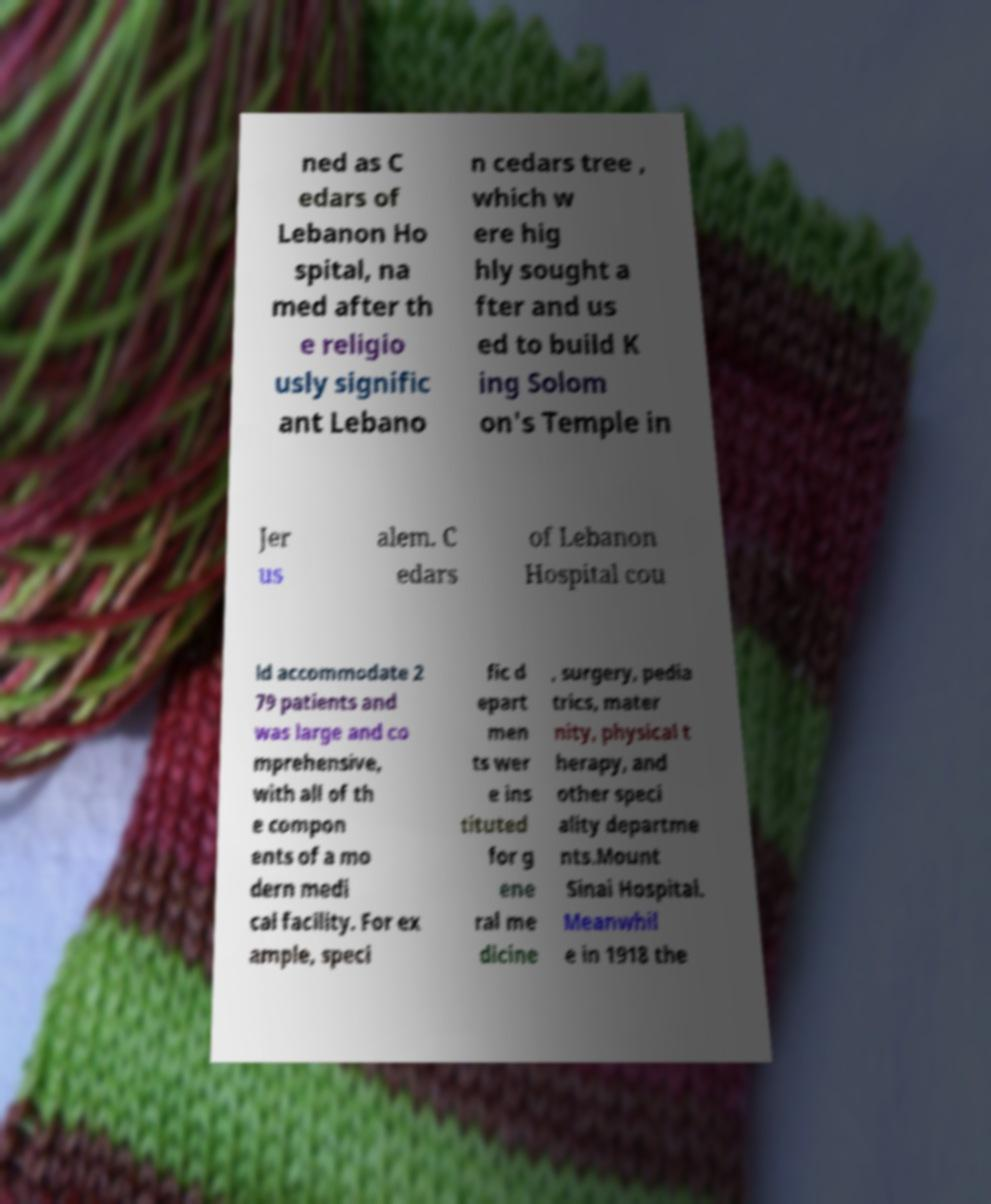Could you extract and type out the text from this image? ned as C edars of Lebanon Ho spital, na med after th e religio usly signific ant Lebano n cedars tree , which w ere hig hly sought a fter and us ed to build K ing Solom on's Temple in Jer us alem. C edars of Lebanon Hospital cou ld accommodate 2 79 patients and was large and co mprehensive, with all of th e compon ents of a mo dern medi cal facility. For ex ample, speci fic d epart men ts wer e ins tituted for g ene ral me dicine , surgery, pedia trics, mater nity, physical t herapy, and other speci ality departme nts.Mount Sinai Hospital. Meanwhil e in 1918 the 